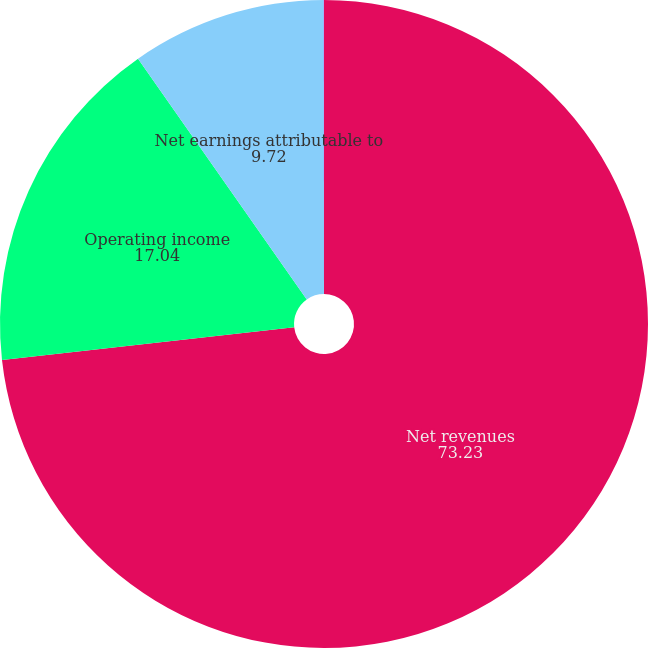Convert chart. <chart><loc_0><loc_0><loc_500><loc_500><pie_chart><fcel>Net revenues<fcel>Operating income<fcel>Net earnings attributable to<fcel>EPS - diluted (1)<nl><fcel>73.23%<fcel>17.04%<fcel>9.72%<fcel>0.01%<nl></chart> 